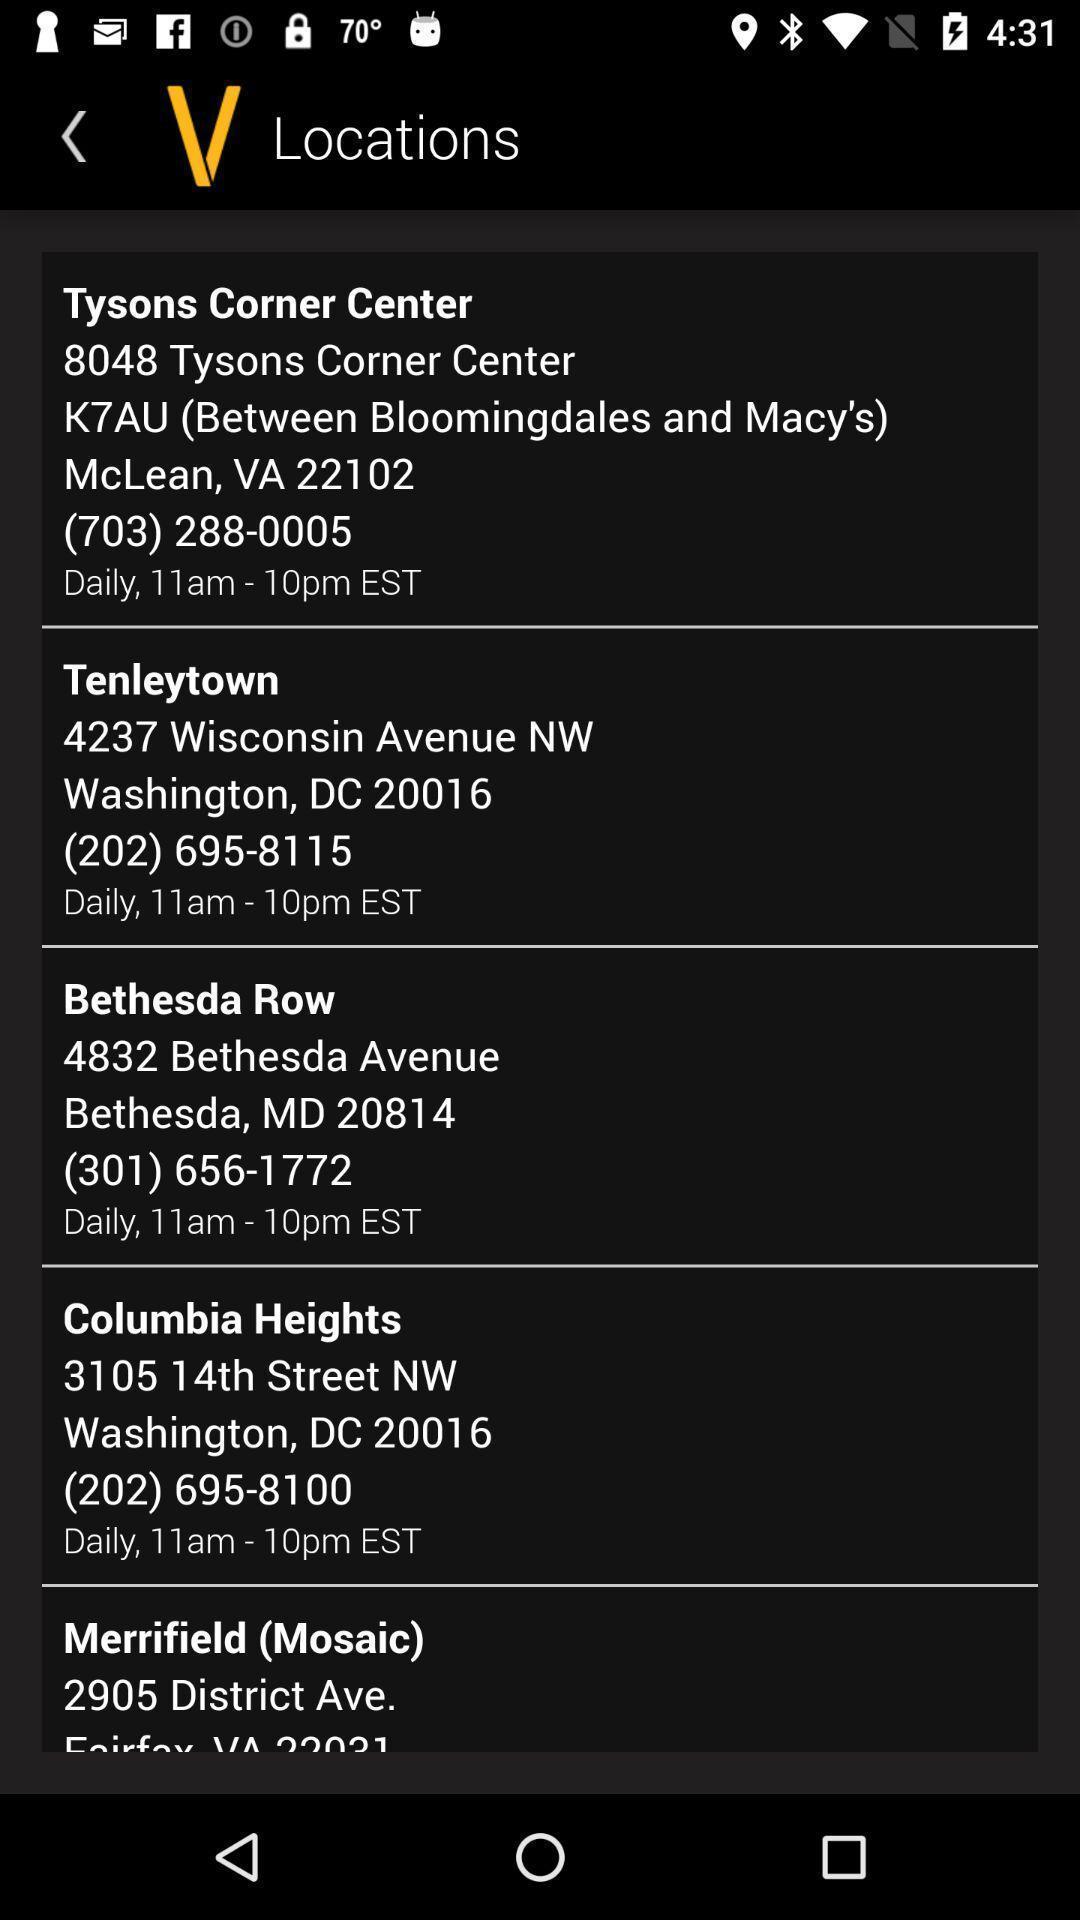Summarize the information in this screenshot. Page displaying the list of different locations. 